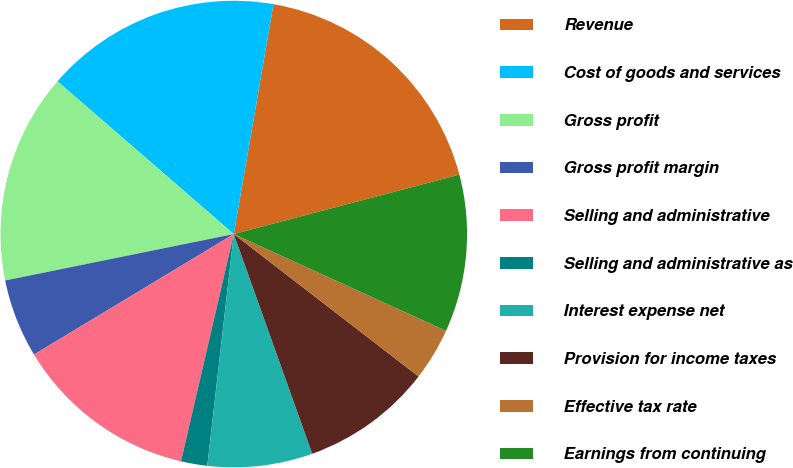Convert chart. <chart><loc_0><loc_0><loc_500><loc_500><pie_chart><fcel>Revenue<fcel>Cost of goods and services<fcel>Gross profit<fcel>Gross profit margin<fcel>Selling and administrative<fcel>Selling and administrative as<fcel>Interest expense net<fcel>Provision for income taxes<fcel>Effective tax rate<fcel>Earnings from continuing<nl><fcel>18.18%<fcel>16.36%<fcel>14.55%<fcel>5.45%<fcel>12.73%<fcel>1.82%<fcel>7.27%<fcel>9.09%<fcel>3.64%<fcel>10.91%<nl></chart> 